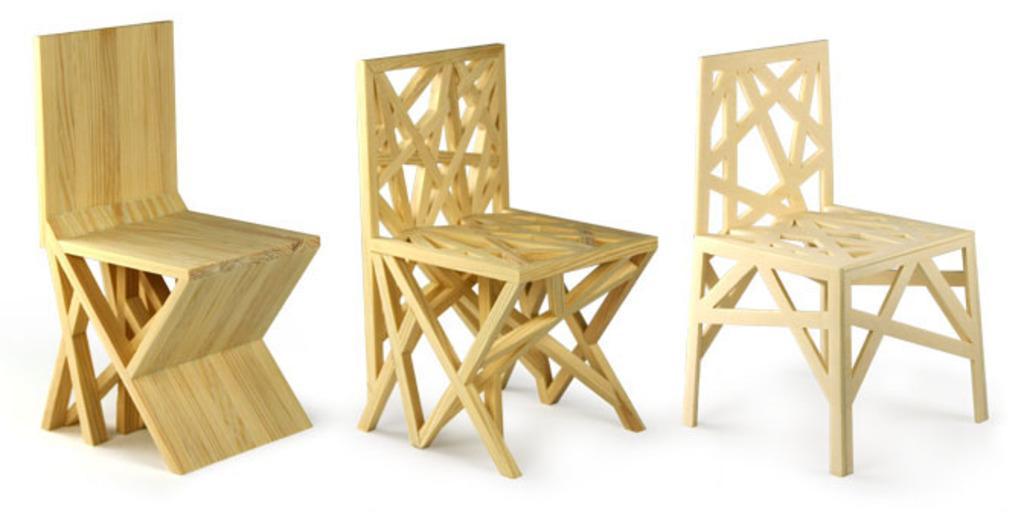Describe this image in one or two sentences. In this image, we can see wooden chairs. 